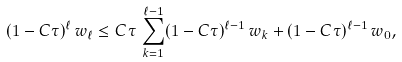Convert formula to latex. <formula><loc_0><loc_0><loc_500><loc_500>( 1 - C \tau ) ^ { \ell } \, w _ { \ell } \leq C \tau \, \sum _ { k = 1 } ^ { \ell - 1 } ( 1 - C \tau ) ^ { \ell - 1 } \, w _ { k } + ( 1 - C \tau ) ^ { \ell - 1 } \, w _ { 0 } ,</formula> 